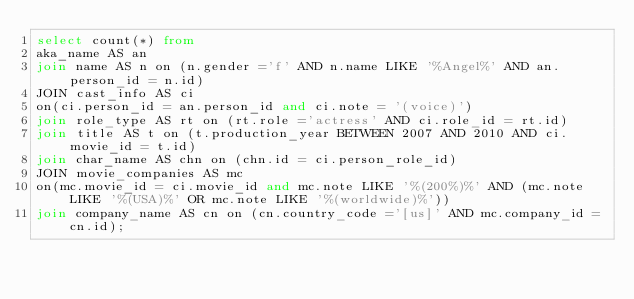Convert code to text. <code><loc_0><loc_0><loc_500><loc_500><_SQL_>select count(*) from 
aka_name AS an 
join name AS n on (n.gender ='f' AND n.name LIKE '%Angel%' AND an.person_id = n.id)
JOIN cast_info AS ci  
on(ci.person_id = an.person_id and ci.note = '(voice)')
join role_type AS rt on (rt.role ='actress' AND ci.role_id = rt.id)
join title AS t on (t.production_year BETWEEN 2007 AND 2010 AND ci.movie_id = t.id)
join char_name AS chn on (chn.id = ci.person_role_id)
JOIN movie_companies AS mc  
on(mc.movie_id = ci.movie_id and mc.note LIKE '%(200%)%' AND (mc.note LIKE '%(USA)%' OR mc.note LIKE '%(worldwide)%'))
join company_name AS cn on (cn.country_code ='[us]' AND mc.company_id = cn.id);</code> 